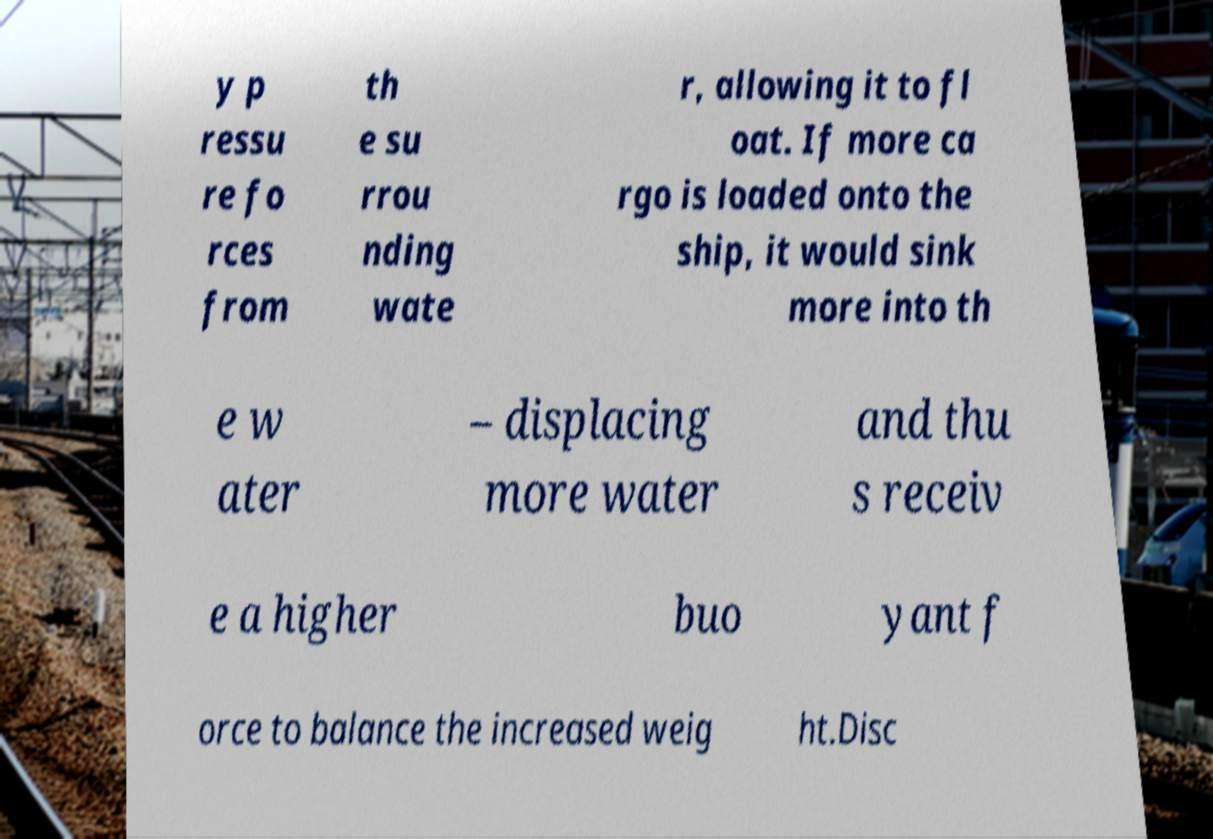Could you assist in decoding the text presented in this image and type it out clearly? y p ressu re fo rces from th e su rrou nding wate r, allowing it to fl oat. If more ca rgo is loaded onto the ship, it would sink more into th e w ater – displacing more water and thu s receiv e a higher buo yant f orce to balance the increased weig ht.Disc 